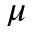Convert formula to latex. <formula><loc_0><loc_0><loc_500><loc_500>\mu</formula> 